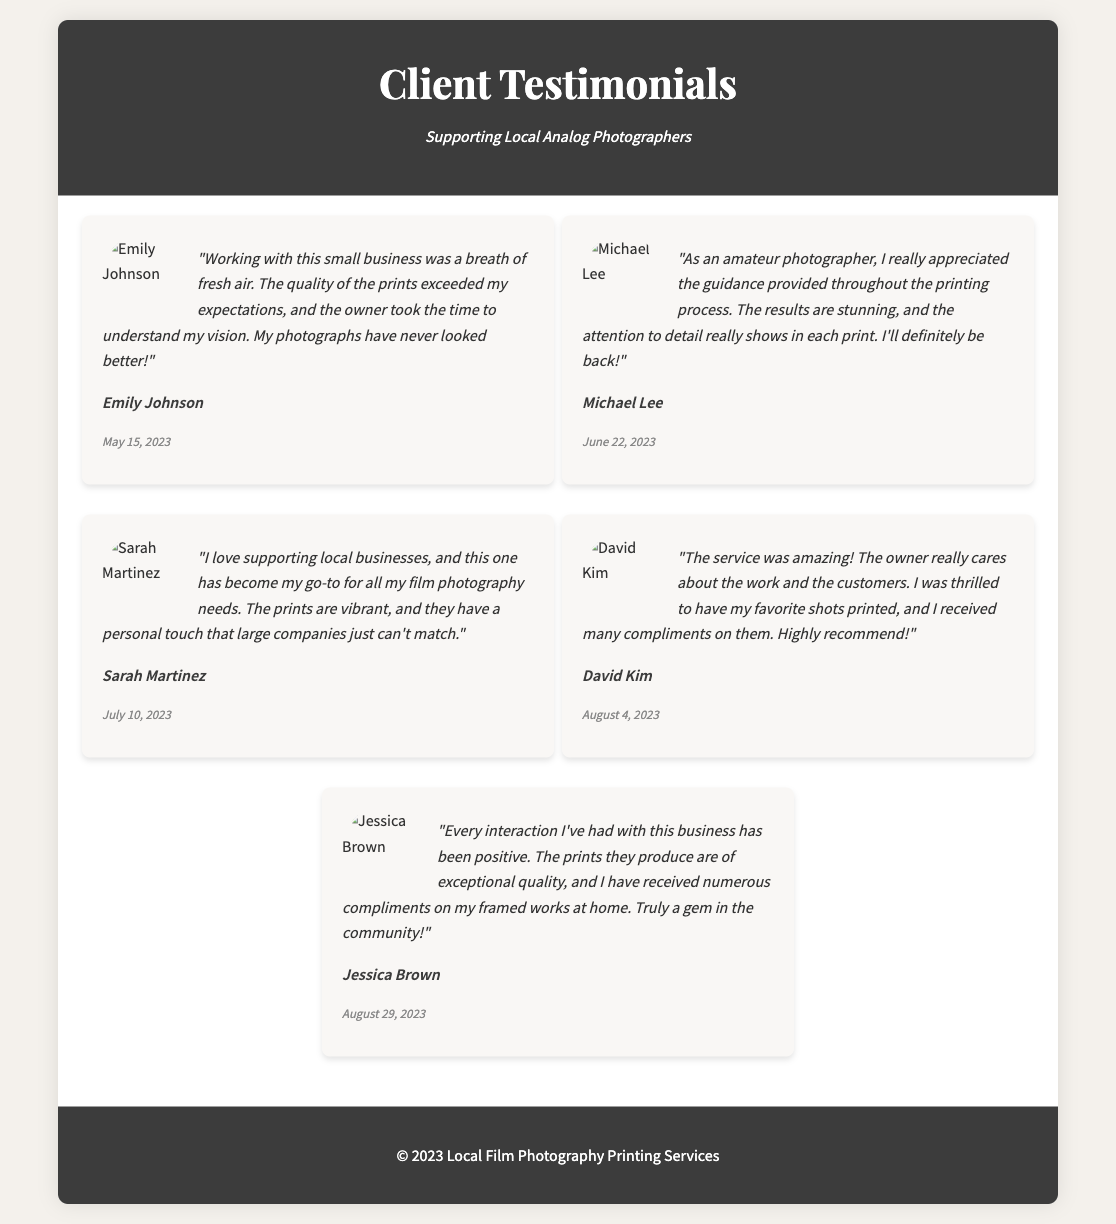What is the title of the document? The title of the document is prominently displayed at the top, indicating the content of the page.
Answer: Client Testimonials Who wrote the testimonial for Michael Lee? Michael Lee shares his experience in the second testimonial; his name is mentioned directly below his feedback.
Answer: Michael Lee What was the date of Sarah Martinez's testimonial? The date is indicated beneath each testimonial, making it easy to find when it was given.
Answer: July 10, 2023 Which client mentioned receiving compliments on their printed photographs? In the testimonials, David Kim specifically notes receiving many compliments on his printed photographs.
Answer: David Kim What is the general sentiment expressed by the clients in their testimonials? Analyzing the testimonials together shows a strong positive sentiment expressed towards the services received.
Answer: Positive How many testimonials are included in the document? The document displays five individual testimonials from different clients, each highlighting their unique experiences.
Answer: Five What kind of photography does this business specialize in? The overarching theme of the testimonials indicates a focus on analog and film photography services and products.
Answer: Film photography What do clients appreciate most about this small business? Evaluating the testimonials reveals a common theme of appreciation for the personal touch and quality of service provided.
Answer: Personal touch What color is the header of the testimonial document? The header color can be noted quickly by observing the design elements at the top of the document.
Answer: Dark gray 